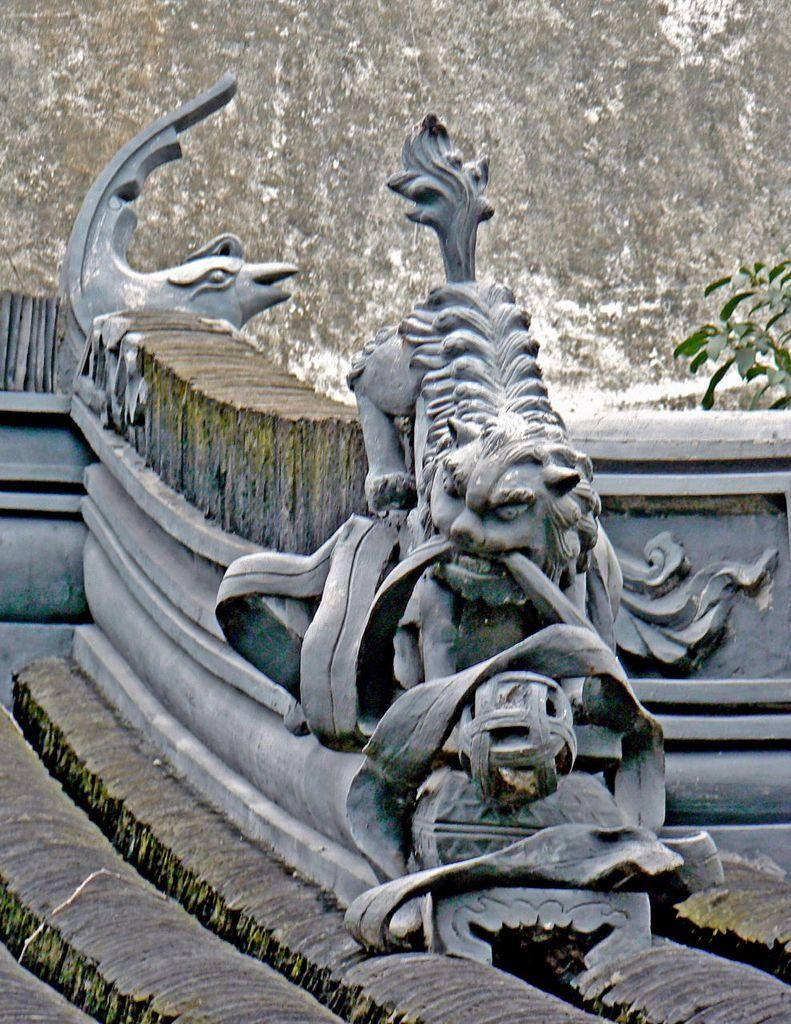What is located in the right corner of the image? There is a statue in the right corner of the image. What type of living organism can be seen in the image? There is a plant in the image. What type of architectural feature is present in the image? There is a wall in the image. What type of tooth is visible in the image? There is no tooth present in the image. What type of dress is the statue wearing in the image? The statue does not have a dress, as it is a statue and not a person. 